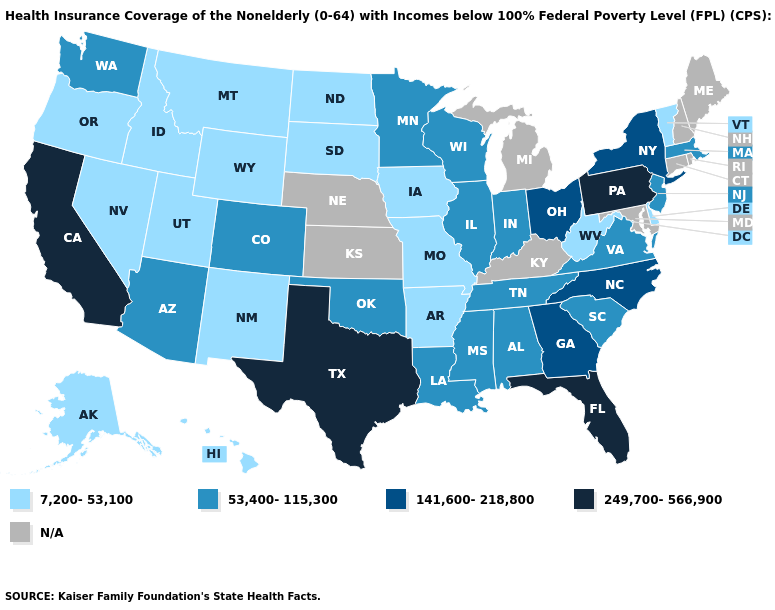What is the lowest value in the West?
Write a very short answer. 7,200-53,100. Name the states that have a value in the range 141,600-218,800?
Keep it brief. Georgia, New York, North Carolina, Ohio. Does the first symbol in the legend represent the smallest category?
Answer briefly. Yes. What is the value of Indiana?
Quick response, please. 53,400-115,300. What is the value of Arizona?
Short answer required. 53,400-115,300. Name the states that have a value in the range N/A?
Quick response, please. Connecticut, Kansas, Kentucky, Maine, Maryland, Michigan, Nebraska, New Hampshire, Rhode Island. What is the highest value in the MidWest ?
Answer briefly. 141,600-218,800. Name the states that have a value in the range 7,200-53,100?
Concise answer only. Alaska, Arkansas, Delaware, Hawaii, Idaho, Iowa, Missouri, Montana, Nevada, New Mexico, North Dakota, Oregon, South Dakota, Utah, Vermont, West Virginia, Wyoming. Name the states that have a value in the range 7,200-53,100?
Keep it brief. Alaska, Arkansas, Delaware, Hawaii, Idaho, Iowa, Missouri, Montana, Nevada, New Mexico, North Dakota, Oregon, South Dakota, Utah, Vermont, West Virginia, Wyoming. What is the value of Georgia?
Short answer required. 141,600-218,800. Does Florida have the highest value in the USA?
Write a very short answer. Yes. Among the states that border Vermont , does New York have the lowest value?
Quick response, please. No. Which states have the highest value in the USA?
Keep it brief. California, Florida, Pennsylvania, Texas. What is the lowest value in the Northeast?
Answer briefly. 7,200-53,100. 